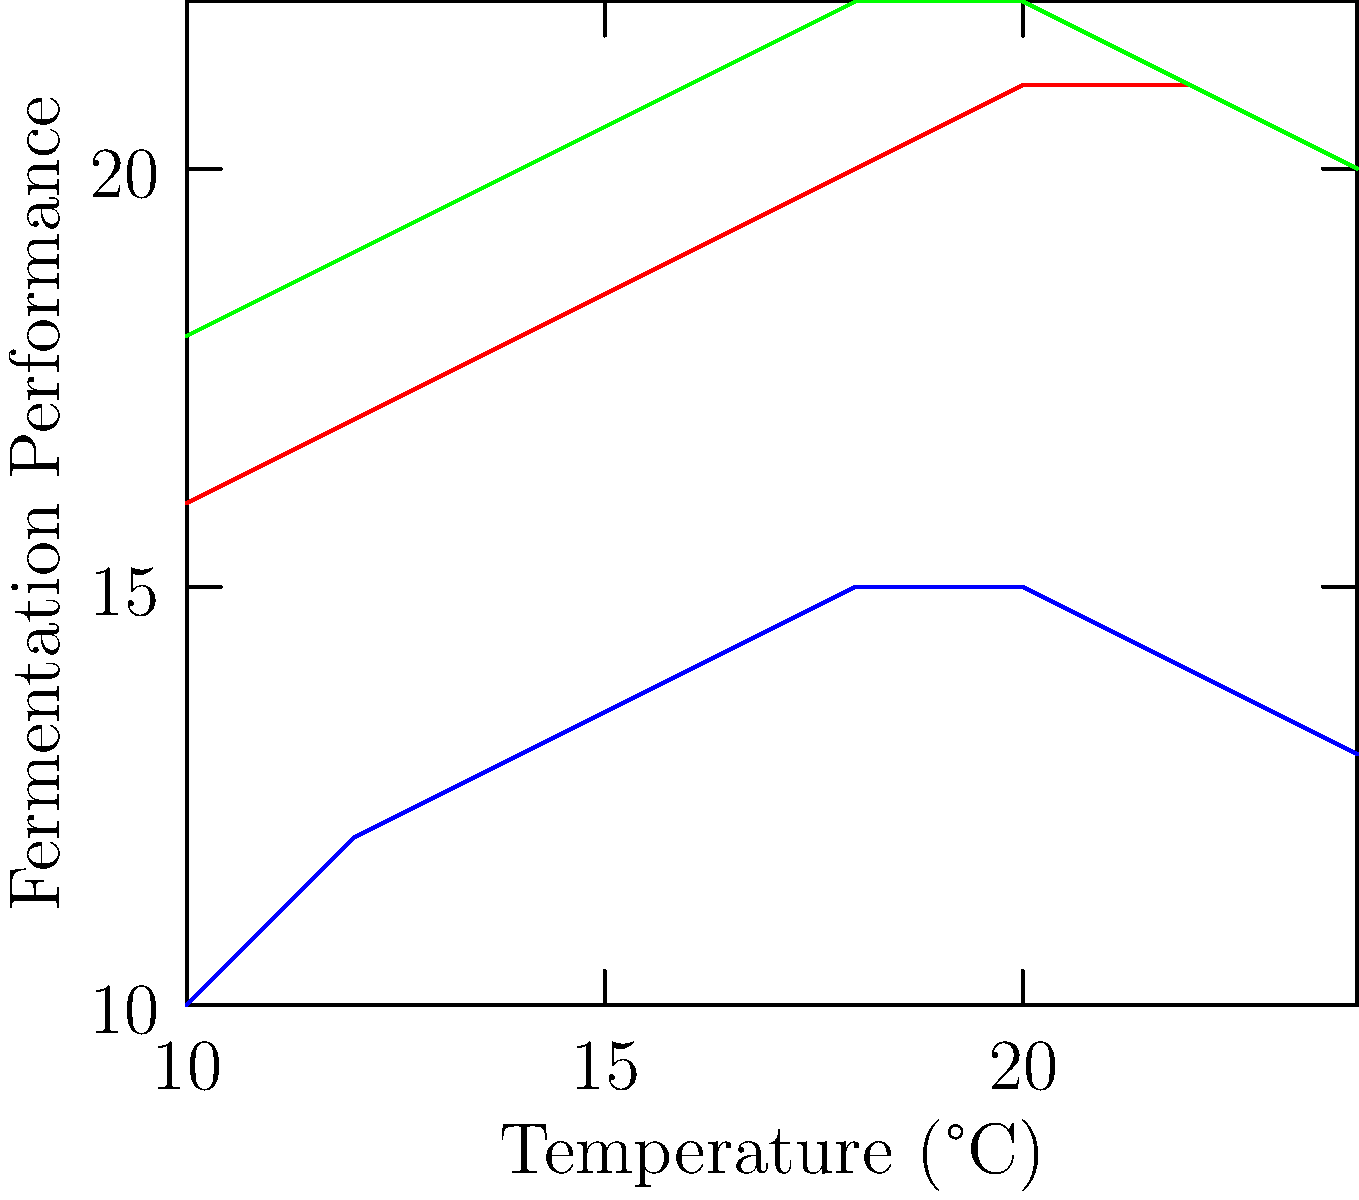Based on the line graph showing fermentation performance for different beer styles across various temperatures, at what temperature does the fermentation performance of ales peak? To determine the peak fermentation temperature for ales, we need to follow these steps:

1. Identify the line representing ales on the graph (red line).
2. Trace the ale line from left to right, observing its trajectory.
3. Find the highest point on the ale line, which represents peak fermentation performance.
4. Identify the corresponding temperature on the x-axis for this peak point.

Looking at the red line representing ales:
- The line starts at a lower performance around 16°C.
- It steadily rises as temperature increases.
- The line reaches its highest point and plateaus between 20°C and 22°C.
- After 22°C, the performance starts to decline slightly.

The peak of the ale line occurs at the start of the plateau, which corresponds to 20°C on the x-axis.

Therefore, the fermentation performance of ales peaks at 20°C according to this graph.
Answer: 20°C 